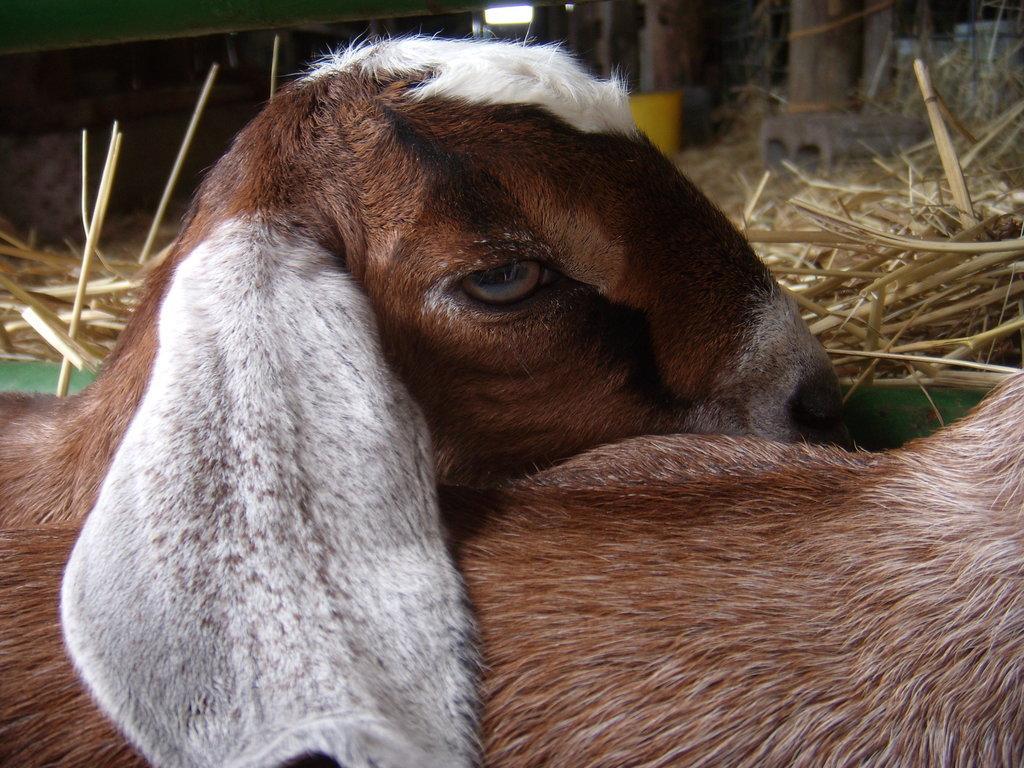How would you summarize this image in a sentence or two? Here we can see two animals. In the background there are poles,grass and other objects. 